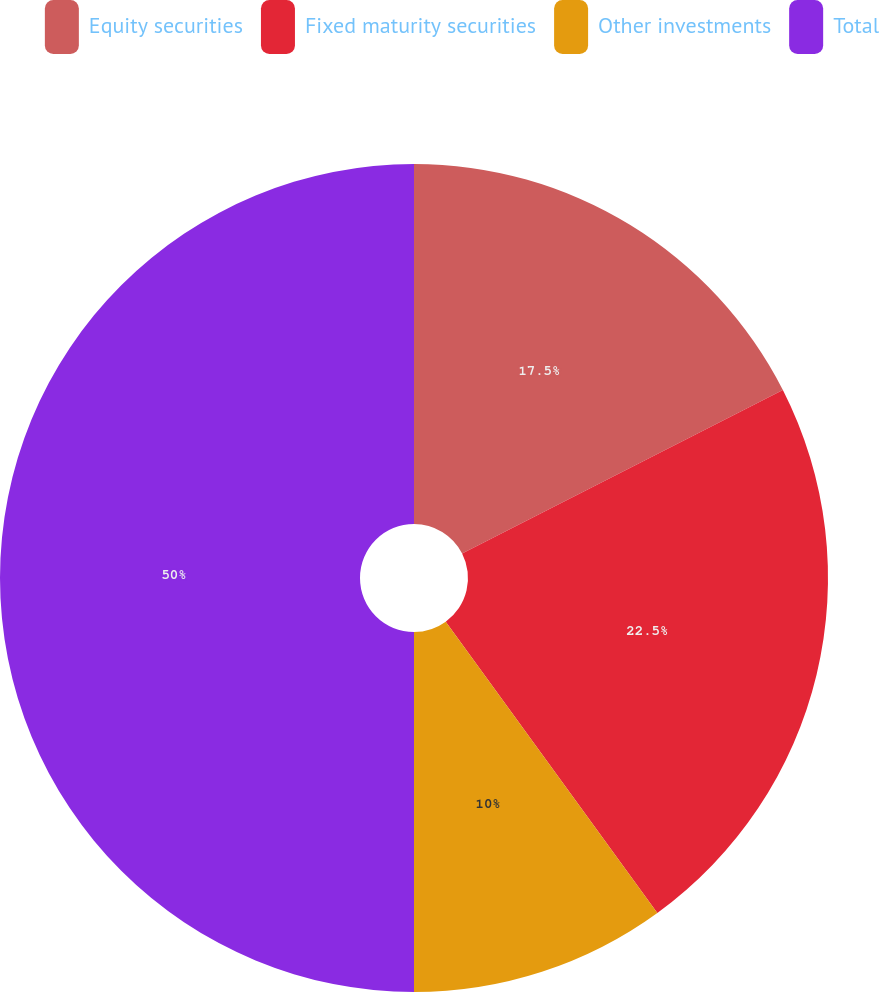Convert chart to OTSL. <chart><loc_0><loc_0><loc_500><loc_500><pie_chart><fcel>Equity securities<fcel>Fixed maturity securities<fcel>Other investments<fcel>Total<nl><fcel>17.5%<fcel>22.5%<fcel>10.0%<fcel>50.0%<nl></chart> 